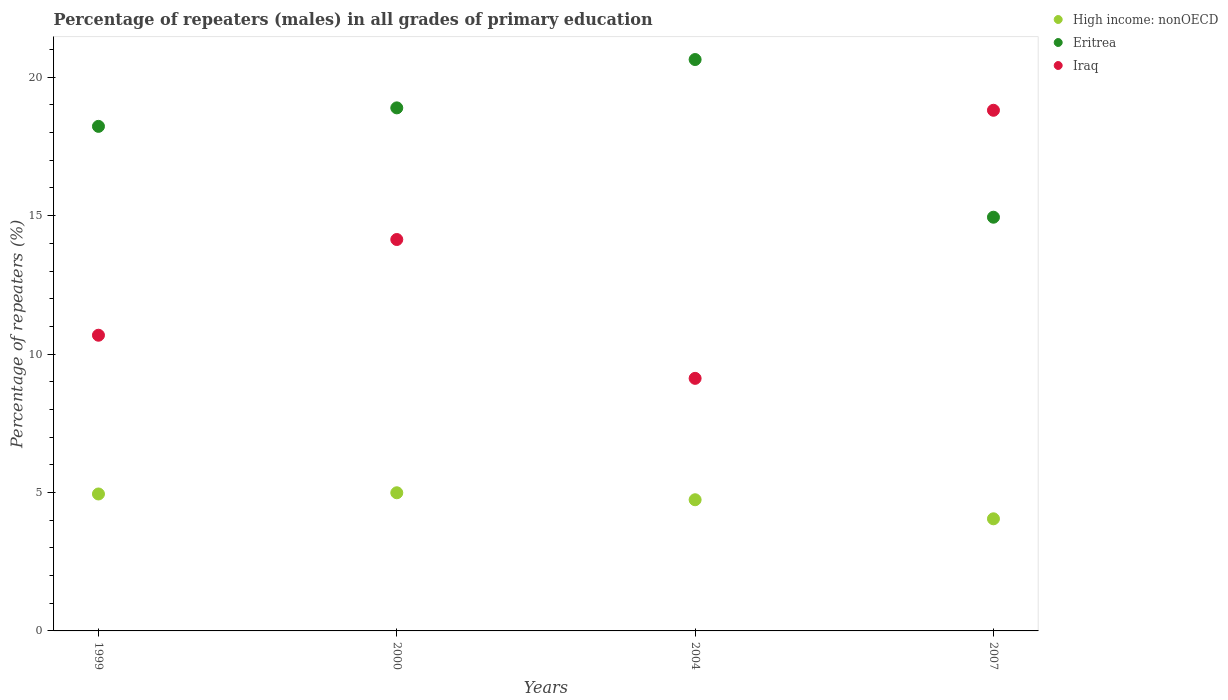Is the number of dotlines equal to the number of legend labels?
Offer a terse response. Yes. What is the percentage of repeaters (males) in Iraq in 2004?
Provide a short and direct response. 9.12. Across all years, what is the maximum percentage of repeaters (males) in Eritrea?
Ensure brevity in your answer.  20.64. Across all years, what is the minimum percentage of repeaters (males) in High income: nonOECD?
Offer a very short reply. 4.05. In which year was the percentage of repeaters (males) in Eritrea minimum?
Offer a terse response. 2007. What is the total percentage of repeaters (males) in Eritrea in the graph?
Your answer should be very brief. 72.7. What is the difference between the percentage of repeaters (males) in Eritrea in 2000 and that in 2004?
Offer a very short reply. -1.75. What is the difference between the percentage of repeaters (males) in High income: nonOECD in 2000 and the percentage of repeaters (males) in Iraq in 2007?
Provide a short and direct response. -13.82. What is the average percentage of repeaters (males) in Iraq per year?
Give a very brief answer. 13.19. In the year 1999, what is the difference between the percentage of repeaters (males) in Iraq and percentage of repeaters (males) in Eritrea?
Provide a short and direct response. -7.54. In how many years, is the percentage of repeaters (males) in Iraq greater than 13 %?
Your response must be concise. 2. What is the ratio of the percentage of repeaters (males) in Eritrea in 2000 to that in 2007?
Provide a succinct answer. 1.26. Is the percentage of repeaters (males) in Eritrea in 1999 less than that in 2004?
Provide a short and direct response. Yes. Is the difference between the percentage of repeaters (males) in Iraq in 1999 and 2000 greater than the difference between the percentage of repeaters (males) in Eritrea in 1999 and 2000?
Keep it short and to the point. No. What is the difference between the highest and the second highest percentage of repeaters (males) in High income: nonOECD?
Give a very brief answer. 0.04. What is the difference between the highest and the lowest percentage of repeaters (males) in Iraq?
Offer a very short reply. 9.68. Is it the case that in every year, the sum of the percentage of repeaters (males) in Iraq and percentage of repeaters (males) in High income: nonOECD  is greater than the percentage of repeaters (males) in Eritrea?
Keep it short and to the point. No. Is the percentage of repeaters (males) in High income: nonOECD strictly greater than the percentage of repeaters (males) in Eritrea over the years?
Provide a short and direct response. No. How many dotlines are there?
Your answer should be very brief. 3. How many years are there in the graph?
Ensure brevity in your answer.  4. What is the difference between two consecutive major ticks on the Y-axis?
Keep it short and to the point. 5. Are the values on the major ticks of Y-axis written in scientific E-notation?
Your answer should be very brief. No. Does the graph contain grids?
Your answer should be very brief. No. Where does the legend appear in the graph?
Your response must be concise. Top right. What is the title of the graph?
Give a very brief answer. Percentage of repeaters (males) in all grades of primary education. Does "Barbados" appear as one of the legend labels in the graph?
Your answer should be compact. No. What is the label or title of the X-axis?
Keep it short and to the point. Years. What is the label or title of the Y-axis?
Provide a succinct answer. Percentage of repeaters (%). What is the Percentage of repeaters (%) of High income: nonOECD in 1999?
Your response must be concise. 4.95. What is the Percentage of repeaters (%) in Eritrea in 1999?
Offer a terse response. 18.23. What is the Percentage of repeaters (%) of Iraq in 1999?
Provide a short and direct response. 10.68. What is the Percentage of repeaters (%) of High income: nonOECD in 2000?
Provide a succinct answer. 4.99. What is the Percentage of repeaters (%) in Eritrea in 2000?
Give a very brief answer. 18.89. What is the Percentage of repeaters (%) of Iraq in 2000?
Offer a terse response. 14.14. What is the Percentage of repeaters (%) in High income: nonOECD in 2004?
Your response must be concise. 4.74. What is the Percentage of repeaters (%) of Eritrea in 2004?
Offer a very short reply. 20.64. What is the Percentage of repeaters (%) in Iraq in 2004?
Keep it short and to the point. 9.12. What is the Percentage of repeaters (%) of High income: nonOECD in 2007?
Your answer should be very brief. 4.05. What is the Percentage of repeaters (%) of Eritrea in 2007?
Keep it short and to the point. 14.94. What is the Percentage of repeaters (%) of Iraq in 2007?
Your answer should be very brief. 18.81. Across all years, what is the maximum Percentage of repeaters (%) in High income: nonOECD?
Ensure brevity in your answer.  4.99. Across all years, what is the maximum Percentage of repeaters (%) in Eritrea?
Provide a succinct answer. 20.64. Across all years, what is the maximum Percentage of repeaters (%) in Iraq?
Your response must be concise. 18.81. Across all years, what is the minimum Percentage of repeaters (%) in High income: nonOECD?
Give a very brief answer. 4.05. Across all years, what is the minimum Percentage of repeaters (%) in Eritrea?
Make the answer very short. 14.94. Across all years, what is the minimum Percentage of repeaters (%) in Iraq?
Ensure brevity in your answer.  9.12. What is the total Percentage of repeaters (%) of High income: nonOECD in the graph?
Make the answer very short. 18.73. What is the total Percentage of repeaters (%) in Eritrea in the graph?
Give a very brief answer. 72.7. What is the total Percentage of repeaters (%) in Iraq in the graph?
Ensure brevity in your answer.  52.75. What is the difference between the Percentage of repeaters (%) of High income: nonOECD in 1999 and that in 2000?
Make the answer very short. -0.04. What is the difference between the Percentage of repeaters (%) of Eritrea in 1999 and that in 2000?
Make the answer very short. -0.67. What is the difference between the Percentage of repeaters (%) of Iraq in 1999 and that in 2000?
Your answer should be very brief. -3.46. What is the difference between the Percentage of repeaters (%) in High income: nonOECD in 1999 and that in 2004?
Make the answer very short. 0.21. What is the difference between the Percentage of repeaters (%) in Eritrea in 1999 and that in 2004?
Keep it short and to the point. -2.41. What is the difference between the Percentage of repeaters (%) in Iraq in 1999 and that in 2004?
Offer a terse response. 1.56. What is the difference between the Percentage of repeaters (%) of High income: nonOECD in 1999 and that in 2007?
Provide a succinct answer. 0.9. What is the difference between the Percentage of repeaters (%) of Eritrea in 1999 and that in 2007?
Offer a terse response. 3.28. What is the difference between the Percentage of repeaters (%) of Iraq in 1999 and that in 2007?
Your answer should be compact. -8.13. What is the difference between the Percentage of repeaters (%) in High income: nonOECD in 2000 and that in 2004?
Ensure brevity in your answer.  0.25. What is the difference between the Percentage of repeaters (%) in Eritrea in 2000 and that in 2004?
Offer a terse response. -1.75. What is the difference between the Percentage of repeaters (%) of Iraq in 2000 and that in 2004?
Offer a terse response. 5.02. What is the difference between the Percentage of repeaters (%) in High income: nonOECD in 2000 and that in 2007?
Your answer should be very brief. 0.94. What is the difference between the Percentage of repeaters (%) of Eritrea in 2000 and that in 2007?
Ensure brevity in your answer.  3.95. What is the difference between the Percentage of repeaters (%) in Iraq in 2000 and that in 2007?
Your answer should be compact. -4.67. What is the difference between the Percentage of repeaters (%) in High income: nonOECD in 2004 and that in 2007?
Make the answer very short. 0.69. What is the difference between the Percentage of repeaters (%) of Eritrea in 2004 and that in 2007?
Ensure brevity in your answer.  5.7. What is the difference between the Percentage of repeaters (%) in Iraq in 2004 and that in 2007?
Ensure brevity in your answer.  -9.68. What is the difference between the Percentage of repeaters (%) of High income: nonOECD in 1999 and the Percentage of repeaters (%) of Eritrea in 2000?
Keep it short and to the point. -13.95. What is the difference between the Percentage of repeaters (%) in High income: nonOECD in 1999 and the Percentage of repeaters (%) in Iraq in 2000?
Offer a terse response. -9.19. What is the difference between the Percentage of repeaters (%) in Eritrea in 1999 and the Percentage of repeaters (%) in Iraq in 2000?
Provide a short and direct response. 4.09. What is the difference between the Percentage of repeaters (%) in High income: nonOECD in 1999 and the Percentage of repeaters (%) in Eritrea in 2004?
Offer a terse response. -15.69. What is the difference between the Percentage of repeaters (%) in High income: nonOECD in 1999 and the Percentage of repeaters (%) in Iraq in 2004?
Keep it short and to the point. -4.18. What is the difference between the Percentage of repeaters (%) of Eritrea in 1999 and the Percentage of repeaters (%) of Iraq in 2004?
Provide a succinct answer. 9.1. What is the difference between the Percentage of repeaters (%) in High income: nonOECD in 1999 and the Percentage of repeaters (%) in Eritrea in 2007?
Offer a terse response. -10. What is the difference between the Percentage of repeaters (%) of High income: nonOECD in 1999 and the Percentage of repeaters (%) of Iraq in 2007?
Provide a succinct answer. -13.86. What is the difference between the Percentage of repeaters (%) in Eritrea in 1999 and the Percentage of repeaters (%) in Iraq in 2007?
Your response must be concise. -0.58. What is the difference between the Percentage of repeaters (%) in High income: nonOECD in 2000 and the Percentage of repeaters (%) in Eritrea in 2004?
Your response must be concise. -15.65. What is the difference between the Percentage of repeaters (%) of High income: nonOECD in 2000 and the Percentage of repeaters (%) of Iraq in 2004?
Your answer should be very brief. -4.13. What is the difference between the Percentage of repeaters (%) of Eritrea in 2000 and the Percentage of repeaters (%) of Iraq in 2004?
Provide a succinct answer. 9.77. What is the difference between the Percentage of repeaters (%) of High income: nonOECD in 2000 and the Percentage of repeaters (%) of Eritrea in 2007?
Make the answer very short. -9.95. What is the difference between the Percentage of repeaters (%) of High income: nonOECD in 2000 and the Percentage of repeaters (%) of Iraq in 2007?
Offer a very short reply. -13.82. What is the difference between the Percentage of repeaters (%) of Eritrea in 2000 and the Percentage of repeaters (%) of Iraq in 2007?
Provide a short and direct response. 0.09. What is the difference between the Percentage of repeaters (%) in High income: nonOECD in 2004 and the Percentage of repeaters (%) in Eritrea in 2007?
Provide a short and direct response. -10.21. What is the difference between the Percentage of repeaters (%) of High income: nonOECD in 2004 and the Percentage of repeaters (%) of Iraq in 2007?
Ensure brevity in your answer.  -14.07. What is the difference between the Percentage of repeaters (%) in Eritrea in 2004 and the Percentage of repeaters (%) in Iraq in 2007?
Make the answer very short. 1.83. What is the average Percentage of repeaters (%) in High income: nonOECD per year?
Your answer should be compact. 4.68. What is the average Percentage of repeaters (%) of Eritrea per year?
Keep it short and to the point. 18.18. What is the average Percentage of repeaters (%) of Iraq per year?
Your response must be concise. 13.19. In the year 1999, what is the difference between the Percentage of repeaters (%) of High income: nonOECD and Percentage of repeaters (%) of Eritrea?
Your response must be concise. -13.28. In the year 1999, what is the difference between the Percentage of repeaters (%) of High income: nonOECD and Percentage of repeaters (%) of Iraq?
Ensure brevity in your answer.  -5.73. In the year 1999, what is the difference between the Percentage of repeaters (%) of Eritrea and Percentage of repeaters (%) of Iraq?
Your response must be concise. 7.54. In the year 2000, what is the difference between the Percentage of repeaters (%) of High income: nonOECD and Percentage of repeaters (%) of Eritrea?
Your response must be concise. -13.9. In the year 2000, what is the difference between the Percentage of repeaters (%) of High income: nonOECD and Percentage of repeaters (%) of Iraq?
Your answer should be very brief. -9.15. In the year 2000, what is the difference between the Percentage of repeaters (%) of Eritrea and Percentage of repeaters (%) of Iraq?
Offer a terse response. 4.75. In the year 2004, what is the difference between the Percentage of repeaters (%) of High income: nonOECD and Percentage of repeaters (%) of Eritrea?
Your answer should be very brief. -15.9. In the year 2004, what is the difference between the Percentage of repeaters (%) of High income: nonOECD and Percentage of repeaters (%) of Iraq?
Make the answer very short. -4.38. In the year 2004, what is the difference between the Percentage of repeaters (%) of Eritrea and Percentage of repeaters (%) of Iraq?
Your response must be concise. 11.52. In the year 2007, what is the difference between the Percentage of repeaters (%) in High income: nonOECD and Percentage of repeaters (%) in Eritrea?
Your answer should be very brief. -10.89. In the year 2007, what is the difference between the Percentage of repeaters (%) of High income: nonOECD and Percentage of repeaters (%) of Iraq?
Your answer should be very brief. -14.76. In the year 2007, what is the difference between the Percentage of repeaters (%) of Eritrea and Percentage of repeaters (%) of Iraq?
Provide a succinct answer. -3.86. What is the ratio of the Percentage of repeaters (%) in High income: nonOECD in 1999 to that in 2000?
Make the answer very short. 0.99. What is the ratio of the Percentage of repeaters (%) of Eritrea in 1999 to that in 2000?
Ensure brevity in your answer.  0.96. What is the ratio of the Percentage of repeaters (%) in Iraq in 1999 to that in 2000?
Your response must be concise. 0.76. What is the ratio of the Percentage of repeaters (%) in High income: nonOECD in 1999 to that in 2004?
Your response must be concise. 1.04. What is the ratio of the Percentage of repeaters (%) in Eritrea in 1999 to that in 2004?
Provide a short and direct response. 0.88. What is the ratio of the Percentage of repeaters (%) in Iraq in 1999 to that in 2004?
Give a very brief answer. 1.17. What is the ratio of the Percentage of repeaters (%) in High income: nonOECD in 1999 to that in 2007?
Provide a succinct answer. 1.22. What is the ratio of the Percentage of repeaters (%) of Eritrea in 1999 to that in 2007?
Offer a very short reply. 1.22. What is the ratio of the Percentage of repeaters (%) of Iraq in 1999 to that in 2007?
Your answer should be very brief. 0.57. What is the ratio of the Percentage of repeaters (%) of High income: nonOECD in 2000 to that in 2004?
Keep it short and to the point. 1.05. What is the ratio of the Percentage of repeaters (%) in Eritrea in 2000 to that in 2004?
Offer a terse response. 0.92. What is the ratio of the Percentage of repeaters (%) of Iraq in 2000 to that in 2004?
Provide a short and direct response. 1.55. What is the ratio of the Percentage of repeaters (%) in High income: nonOECD in 2000 to that in 2007?
Provide a short and direct response. 1.23. What is the ratio of the Percentage of repeaters (%) of Eritrea in 2000 to that in 2007?
Offer a very short reply. 1.26. What is the ratio of the Percentage of repeaters (%) of Iraq in 2000 to that in 2007?
Offer a very short reply. 0.75. What is the ratio of the Percentage of repeaters (%) in High income: nonOECD in 2004 to that in 2007?
Your response must be concise. 1.17. What is the ratio of the Percentage of repeaters (%) in Eritrea in 2004 to that in 2007?
Give a very brief answer. 1.38. What is the ratio of the Percentage of repeaters (%) in Iraq in 2004 to that in 2007?
Your answer should be compact. 0.49. What is the difference between the highest and the second highest Percentage of repeaters (%) of High income: nonOECD?
Make the answer very short. 0.04. What is the difference between the highest and the second highest Percentage of repeaters (%) of Eritrea?
Provide a succinct answer. 1.75. What is the difference between the highest and the second highest Percentage of repeaters (%) in Iraq?
Keep it short and to the point. 4.67. What is the difference between the highest and the lowest Percentage of repeaters (%) of High income: nonOECD?
Offer a terse response. 0.94. What is the difference between the highest and the lowest Percentage of repeaters (%) in Eritrea?
Offer a very short reply. 5.7. What is the difference between the highest and the lowest Percentage of repeaters (%) in Iraq?
Offer a very short reply. 9.68. 